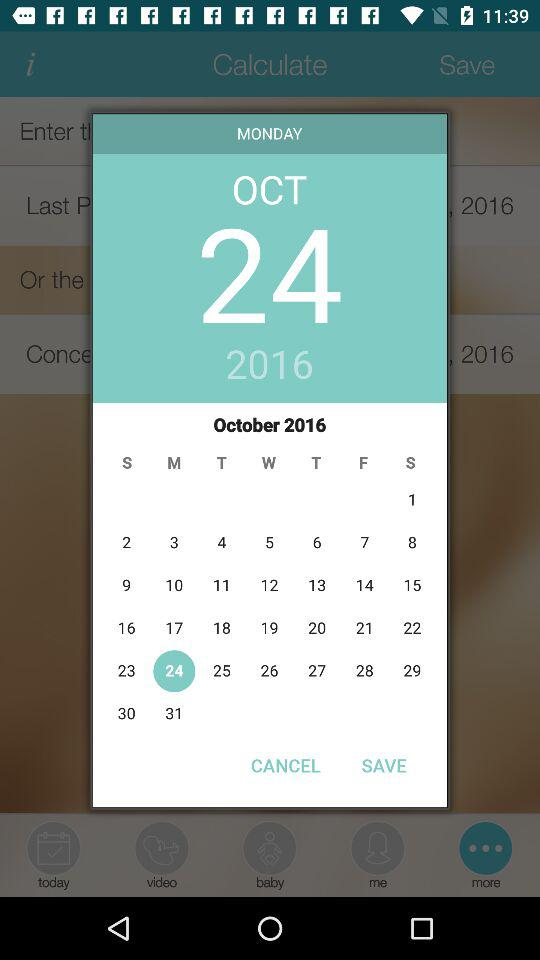How old is the baby?
When the provided information is insufficient, respond with <no answer>. <no answer> 